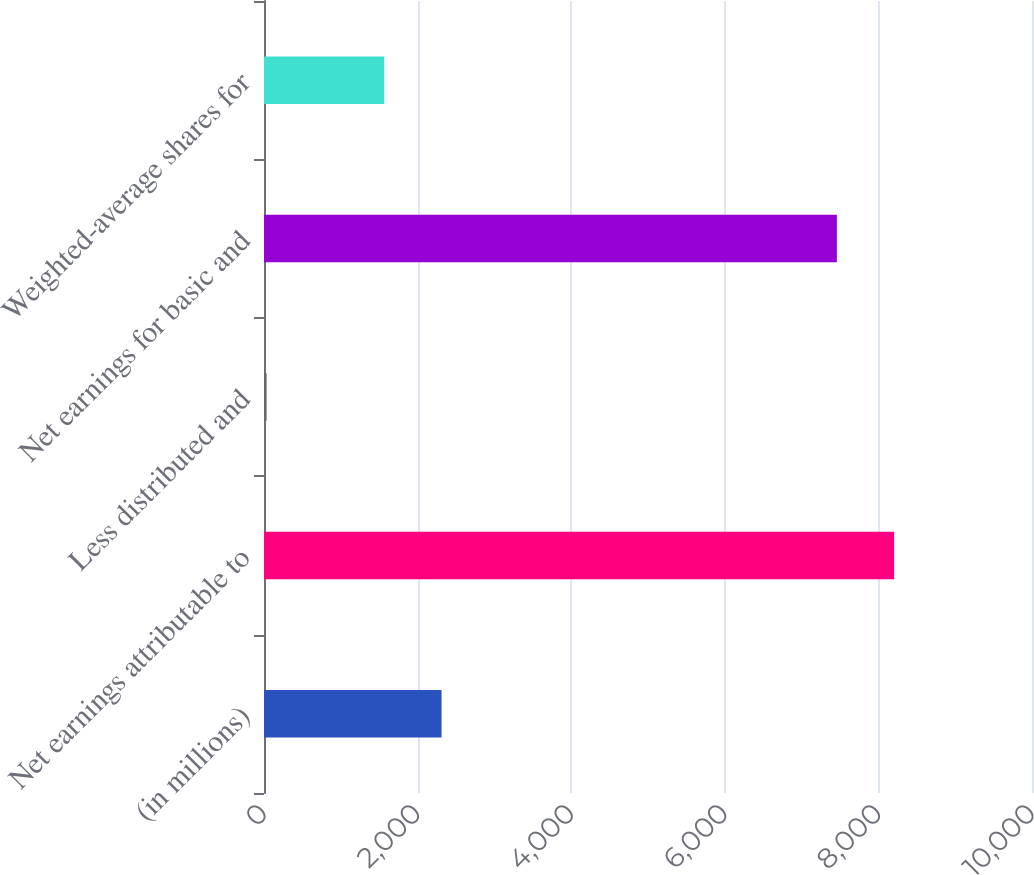Convert chart. <chart><loc_0><loc_0><loc_500><loc_500><bar_chart><fcel>(in millions)<fcel>Net earnings attributable to<fcel>Less distributed and<fcel>Net earnings for basic and<fcel>Weighted-average shares for<nl><fcel>2311.9<fcel>8204.9<fcel>34<fcel>7459<fcel>1566<nl></chart> 